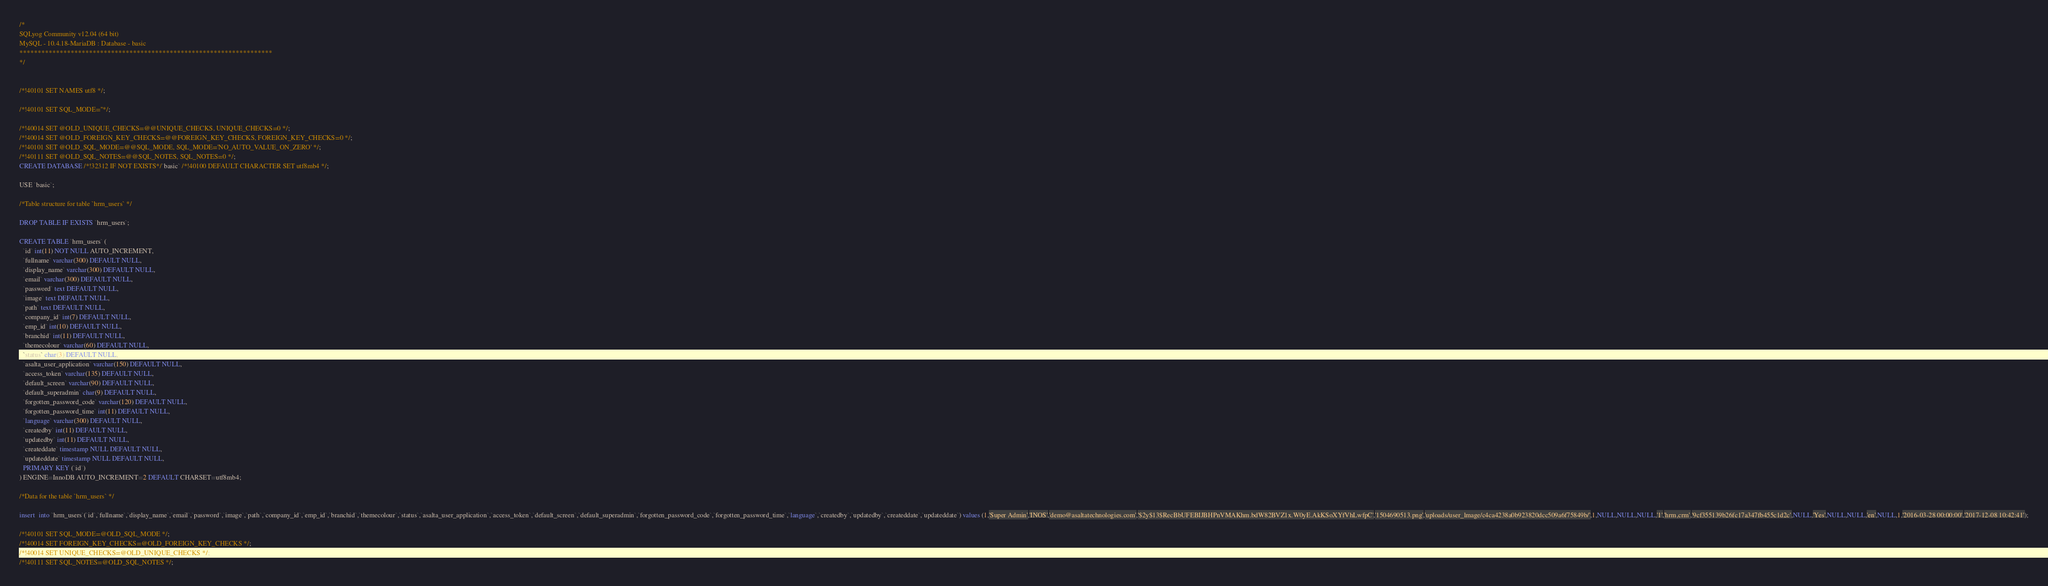<code> <loc_0><loc_0><loc_500><loc_500><_SQL_>/*
SQLyog Community v12.04 (64 bit)
MySQL - 10.4.18-MariaDB : Database - basic
*********************************************************************
*/

/*!40101 SET NAMES utf8 */;

/*!40101 SET SQL_MODE=''*/;

/*!40014 SET @OLD_UNIQUE_CHECKS=@@UNIQUE_CHECKS, UNIQUE_CHECKS=0 */;
/*!40014 SET @OLD_FOREIGN_KEY_CHECKS=@@FOREIGN_KEY_CHECKS, FOREIGN_KEY_CHECKS=0 */;
/*!40101 SET @OLD_SQL_MODE=@@SQL_MODE, SQL_MODE='NO_AUTO_VALUE_ON_ZERO' */;
/*!40111 SET @OLD_SQL_NOTES=@@SQL_NOTES, SQL_NOTES=0 */;
CREATE DATABASE /*!32312 IF NOT EXISTS*/`basic` /*!40100 DEFAULT CHARACTER SET utf8mb4 */;

USE `basic`;

/*Table structure for table `hrm_users` */

DROP TABLE IF EXISTS `hrm_users`;

CREATE TABLE `hrm_users` (
  `id` int(11) NOT NULL AUTO_INCREMENT,
  `fullname` varchar(300) DEFAULT NULL,
  `display_name` varchar(300) DEFAULT NULL,
  `email` varchar(300) DEFAULT NULL,
  `password` text DEFAULT NULL,
  `image` text DEFAULT NULL,
  `path` text DEFAULT NULL,
  `company_id` int(7) DEFAULT NULL,
  `emp_id` int(10) DEFAULT NULL,
  `branchid` int(11) DEFAULT NULL,
  `themecolour` varchar(60) DEFAULT NULL,
  `status` char(3) DEFAULT NULL,
  `asalta_user_application` varchar(150) DEFAULT NULL,
  `access_token` varchar(135) DEFAULT NULL,
  `default_screen` varchar(90) DEFAULT NULL,
  `default_superadmin` char(9) DEFAULT NULL,
  `forgotten_password_code` varchar(120) DEFAULT NULL,
  `forgotten_password_time` int(11) DEFAULT NULL,
  `language` varchar(300) DEFAULT NULL,
  `createdby` int(11) DEFAULT NULL,
  `updatedby` int(11) DEFAULT NULL,
  `createddate` timestamp NULL DEFAULT NULL,
  `updateddate` timestamp NULL DEFAULT NULL,
  PRIMARY KEY (`id`)
) ENGINE=InnoDB AUTO_INCREMENT=2 DEFAULT CHARSET=utf8mb4;

/*Data for the table `hrm_users` */

insert  into `hrm_users`(`id`,`fullname`,`display_name`,`email`,`password`,`image`,`path`,`company_id`,`emp_id`,`branchid`,`themecolour`,`status`,`asalta_user_application`,`access_token`,`default_screen`,`default_superadmin`,`forgotten_password_code`,`forgotten_password_time`,`language`,`createdby`,`updatedby`,`createddate`,`updateddate`) values (1,'Super Admin','INOS','demo@asaltatechnologies.com','$2y$13$RecBbUFEBIJBHPnVMAKhm.bdW82BVZ1x.W0yE.AkKSoXYfVhLwfpC','1504690513.png','uploads/user_lmage/c4ca4238a0b923820dcc509a6f75849b/',1,NULL,NULL,NULL,'1','hrm,crm','9cf355139b26fc17a347fb455c1d2c',NULL,'Yes',NULL,NULL,'en',NULL,1,'2016-03-28 00:00:00','2017-12-08 10:42:41');

/*!40101 SET SQL_MODE=@OLD_SQL_MODE */;
/*!40014 SET FOREIGN_KEY_CHECKS=@OLD_FOREIGN_KEY_CHECKS */;
/*!40014 SET UNIQUE_CHECKS=@OLD_UNIQUE_CHECKS */;
/*!40111 SET SQL_NOTES=@OLD_SQL_NOTES */;
</code> 